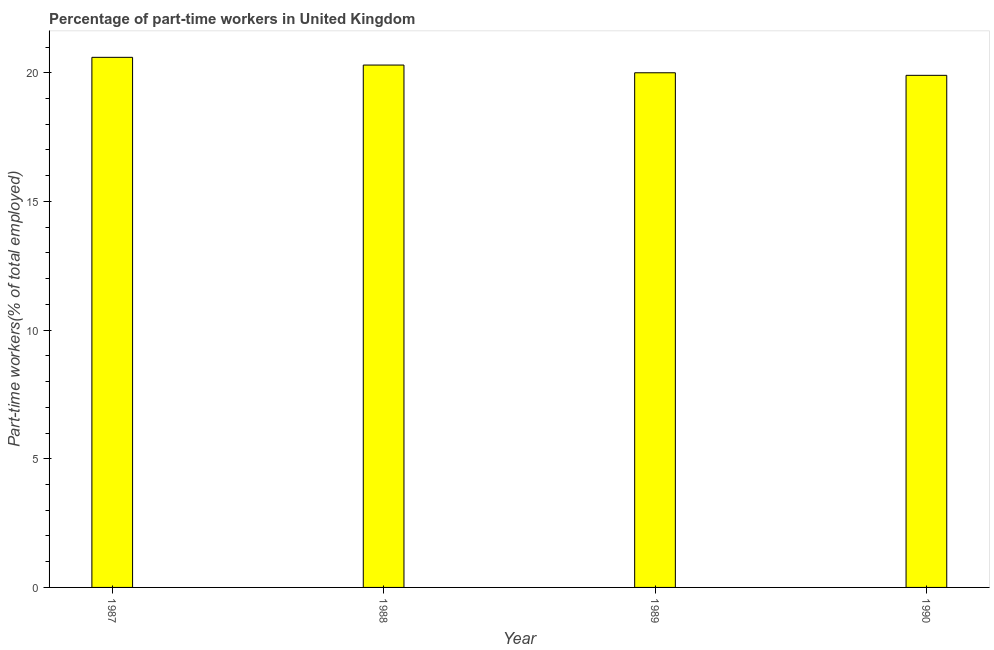Does the graph contain grids?
Offer a very short reply. No. What is the title of the graph?
Keep it short and to the point. Percentage of part-time workers in United Kingdom. What is the label or title of the X-axis?
Your response must be concise. Year. What is the label or title of the Y-axis?
Your answer should be compact. Part-time workers(% of total employed). What is the percentage of part-time workers in 1988?
Your response must be concise. 20.3. Across all years, what is the maximum percentage of part-time workers?
Keep it short and to the point. 20.6. Across all years, what is the minimum percentage of part-time workers?
Provide a short and direct response. 19.9. In which year was the percentage of part-time workers maximum?
Make the answer very short. 1987. What is the sum of the percentage of part-time workers?
Offer a terse response. 80.8. What is the average percentage of part-time workers per year?
Give a very brief answer. 20.2. What is the median percentage of part-time workers?
Your response must be concise. 20.15. In how many years, is the percentage of part-time workers greater than 3 %?
Your response must be concise. 4. Do a majority of the years between 1987 and 1989 (inclusive) have percentage of part-time workers greater than 5 %?
Your answer should be very brief. Yes. What is the ratio of the percentage of part-time workers in 1988 to that in 1990?
Provide a short and direct response. 1.02. Is the percentage of part-time workers in 1988 less than that in 1989?
Make the answer very short. No. Is the difference between the percentage of part-time workers in 1989 and 1990 greater than the difference between any two years?
Ensure brevity in your answer.  No. What is the difference between the highest and the second highest percentage of part-time workers?
Make the answer very short. 0.3. Is the sum of the percentage of part-time workers in 1987 and 1990 greater than the maximum percentage of part-time workers across all years?
Keep it short and to the point. Yes. What is the difference between the highest and the lowest percentage of part-time workers?
Give a very brief answer. 0.7. How many bars are there?
Your answer should be compact. 4. Are all the bars in the graph horizontal?
Ensure brevity in your answer.  No. What is the Part-time workers(% of total employed) in 1987?
Keep it short and to the point. 20.6. What is the Part-time workers(% of total employed) in 1988?
Your response must be concise. 20.3. What is the Part-time workers(% of total employed) in 1990?
Your answer should be very brief. 19.9. What is the difference between the Part-time workers(% of total employed) in 1987 and 1988?
Your response must be concise. 0.3. What is the difference between the Part-time workers(% of total employed) in 1988 and 1990?
Keep it short and to the point. 0.4. What is the difference between the Part-time workers(% of total employed) in 1989 and 1990?
Provide a succinct answer. 0.1. What is the ratio of the Part-time workers(% of total employed) in 1987 to that in 1988?
Ensure brevity in your answer.  1.01. What is the ratio of the Part-time workers(% of total employed) in 1987 to that in 1990?
Provide a succinct answer. 1.03. What is the ratio of the Part-time workers(% of total employed) in 1989 to that in 1990?
Give a very brief answer. 1. 